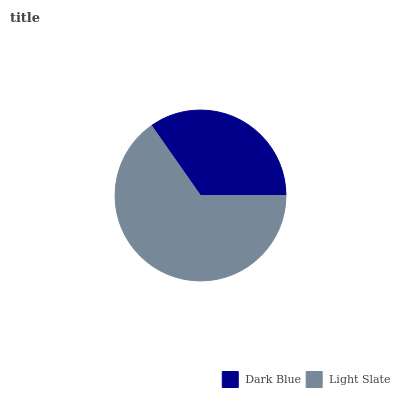Is Dark Blue the minimum?
Answer yes or no. Yes. Is Light Slate the maximum?
Answer yes or no. Yes. Is Light Slate the minimum?
Answer yes or no. No. Is Light Slate greater than Dark Blue?
Answer yes or no. Yes. Is Dark Blue less than Light Slate?
Answer yes or no. Yes. Is Dark Blue greater than Light Slate?
Answer yes or no. No. Is Light Slate less than Dark Blue?
Answer yes or no. No. Is Light Slate the high median?
Answer yes or no. Yes. Is Dark Blue the low median?
Answer yes or no. Yes. Is Dark Blue the high median?
Answer yes or no. No. Is Light Slate the low median?
Answer yes or no. No. 